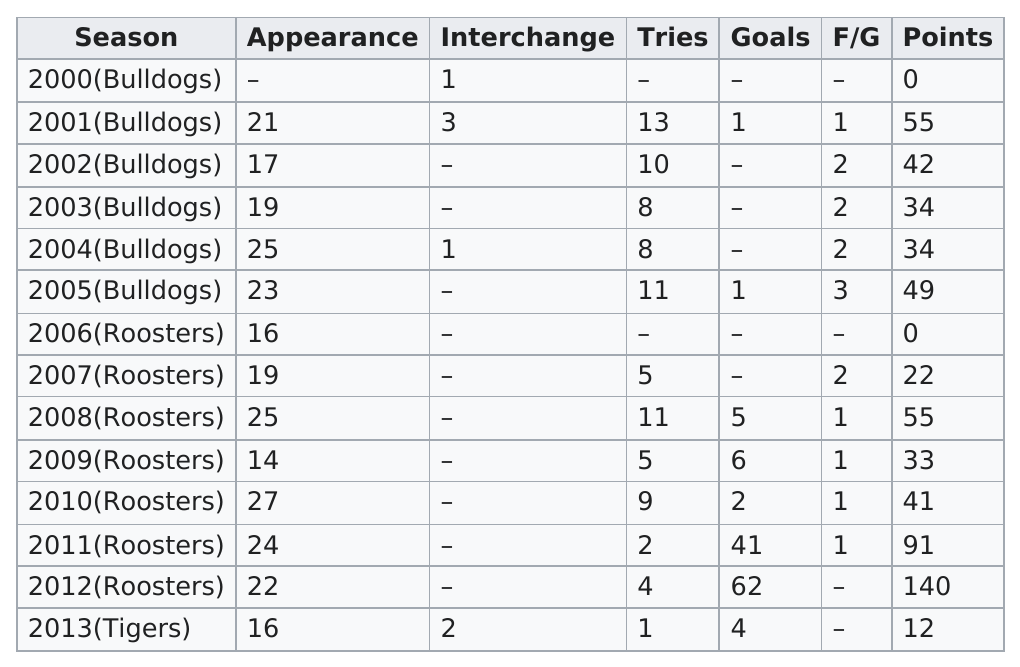Outline some significant characteristics in this image. The Roosters had the most goals in a year out of the three team options provided: Bulldogs, Roosters, and Tigers. In 2009, the person had more goals than they had in 2005 by 5 goals. Anasta played for the Roosters for the longest duration among all the professional teams he played for. Seven seasons saw the teams score above 40 points. The average of all 14 interchanges is 1.75. 